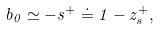Convert formula to latex. <formula><loc_0><loc_0><loc_500><loc_500>b _ { 0 } \simeq - s ^ { + } \doteq 1 - z ^ { + } _ { s } ,</formula> 